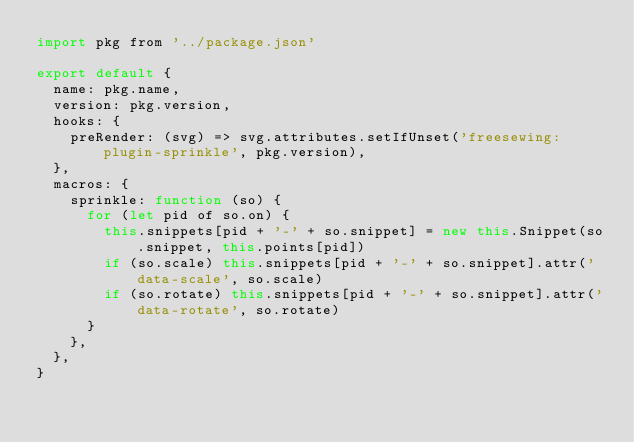<code> <loc_0><loc_0><loc_500><loc_500><_JavaScript_>import pkg from '../package.json'

export default {
  name: pkg.name,
  version: pkg.version,
  hooks: {
    preRender: (svg) => svg.attributes.setIfUnset('freesewing:plugin-sprinkle', pkg.version),
  },
  macros: {
    sprinkle: function (so) {
      for (let pid of so.on) {
        this.snippets[pid + '-' + so.snippet] = new this.Snippet(so.snippet, this.points[pid])
        if (so.scale) this.snippets[pid + '-' + so.snippet].attr('data-scale', so.scale)
        if (so.rotate) this.snippets[pid + '-' + so.snippet].attr('data-rotate', so.rotate)
      }
    },
  },
}
</code> 